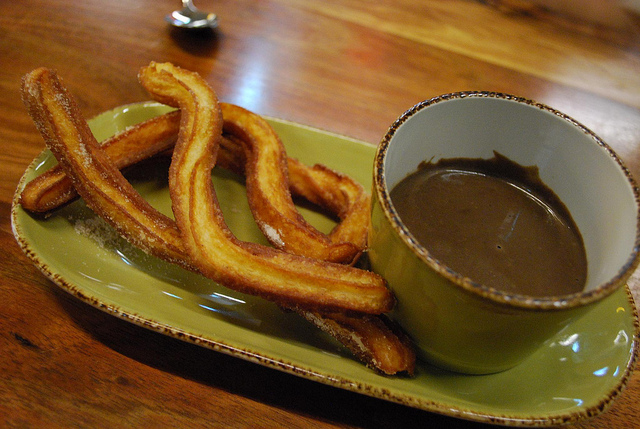What color are the dishes? The dishes are green, which provides a nice contrast with the churros and chocolate. 